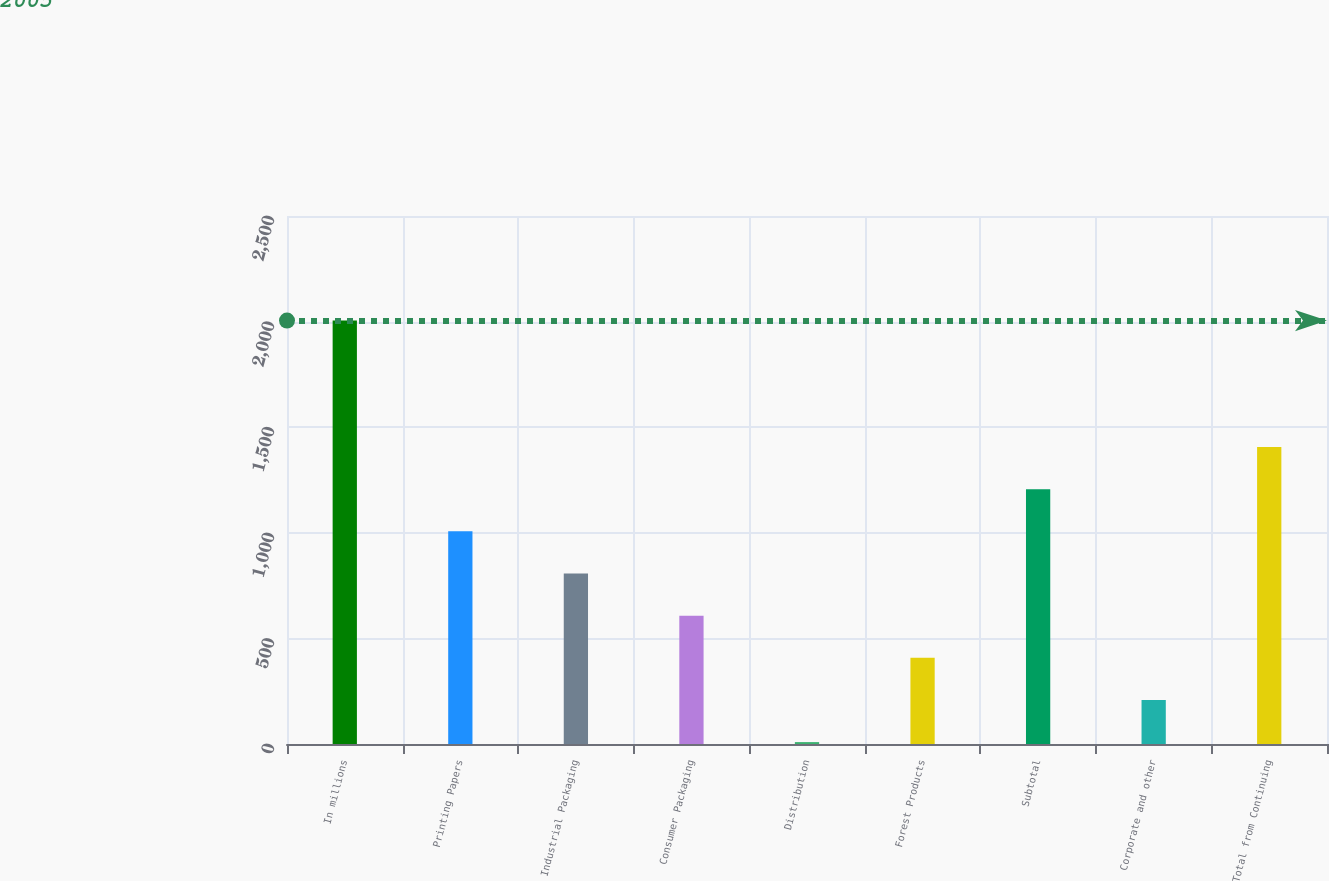Convert chart. <chart><loc_0><loc_0><loc_500><loc_500><bar_chart><fcel>In millions<fcel>Printing Papers<fcel>Industrial Packaging<fcel>Consumer Packaging<fcel>Distribution<fcel>Forest Products<fcel>Subtotal<fcel>Corporate and other<fcel>Total from Continuing<nl><fcel>2005<fcel>1007<fcel>807.4<fcel>607.8<fcel>9<fcel>408.2<fcel>1206.6<fcel>208.6<fcel>1406.2<nl></chart> 